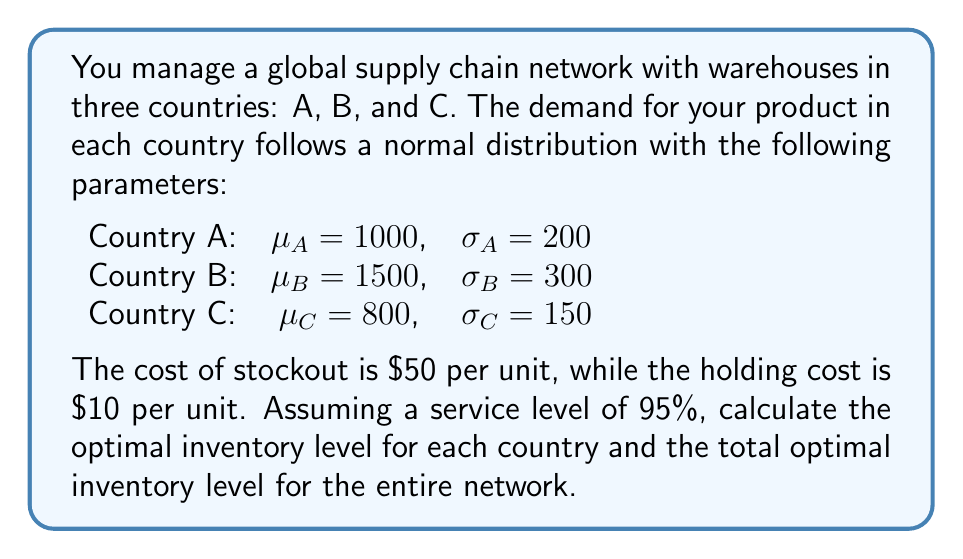Show me your answer to this math problem. To solve this problem, we'll follow these steps:

1. Calculate the optimal inventory level for each country using the newsvendor model.
2. Sum up the individual optimal inventory levels to get the total for the network.

The newsvendor model formula for optimal inventory level is:

$$ Q^* = \mu + z \sigma $$

Where:
$Q^*$ is the optimal inventory level
$\mu$ is the mean demand
$\sigma$ is the standard deviation of demand
$z$ is the z-score for the desired service level

For a 95% service level, $z = 1.645$ (from standard normal distribution table)

Let's calculate for each country:

Country A:
$$ Q^*_A = 1000 + 1.645 \times 200 = 1329 $$

Country B:
$$ Q^*_B = 1500 + 1.645 \times 300 = 1993.5 $$

Country C:
$$ Q^*_C = 800 + 1.645 \times 150 = 1046.75 $$

Now, we sum up these values to get the total optimal inventory level for the network:

$$ Q^*_{total} = Q^*_A + Q^*_B + Q^*_C = 1329 + 1993.5 + 1046.75 = 4369.25 $$

Rounding to the nearest whole number (as we can't have fractional inventory), we get 4369 units.
Answer: 4369 units 